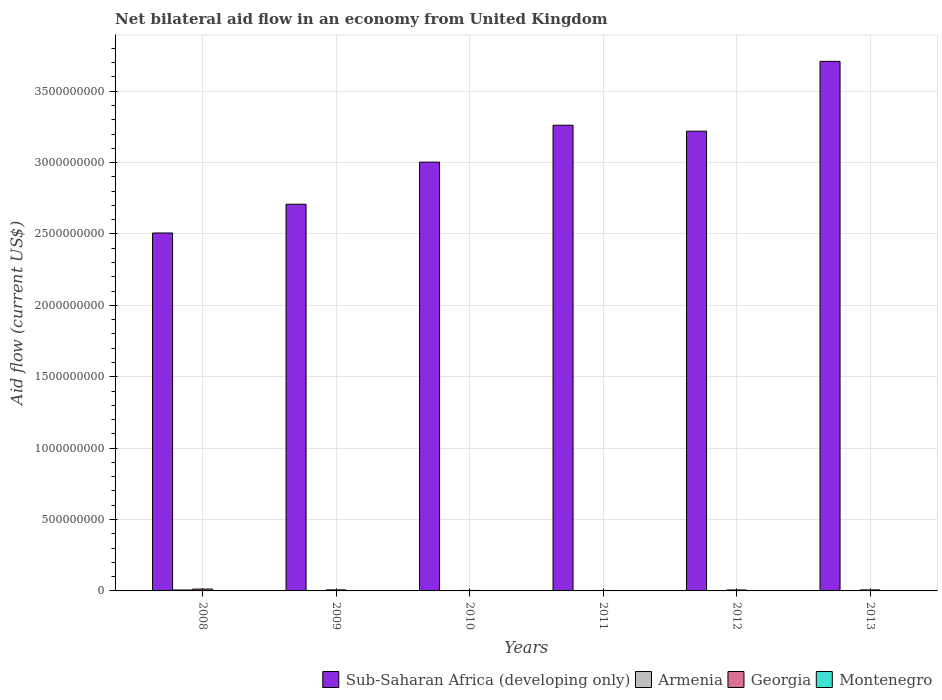Are the number of bars on each tick of the X-axis equal?
Offer a very short reply. Yes. How many bars are there on the 6th tick from the left?
Your answer should be compact. 4. How many bars are there on the 4th tick from the right?
Your answer should be very brief. 4. What is the net bilateral aid flow in Georgia in 2010?
Provide a succinct answer. 3.43e+06. Across all years, what is the maximum net bilateral aid flow in Montenegro?
Ensure brevity in your answer.  8.40e+05. Across all years, what is the minimum net bilateral aid flow in Armenia?
Keep it short and to the point. 3.60e+05. What is the total net bilateral aid flow in Sub-Saharan Africa (developing only) in the graph?
Provide a short and direct response. 1.84e+1. What is the difference between the net bilateral aid flow in Montenegro in 2008 and that in 2013?
Offer a terse response. -1.00e+05. What is the difference between the net bilateral aid flow in Georgia in 2012 and the net bilateral aid flow in Montenegro in 2013?
Your response must be concise. 5.93e+06. What is the average net bilateral aid flow in Armenia per year?
Offer a very short reply. 1.85e+06. In the year 2008, what is the difference between the net bilateral aid flow in Montenegro and net bilateral aid flow in Armenia?
Your answer should be very brief. -5.86e+06. What is the ratio of the net bilateral aid flow in Sub-Saharan Africa (developing only) in 2011 to that in 2012?
Give a very brief answer. 1.01. Is the difference between the net bilateral aid flow in Montenegro in 2011 and 2012 greater than the difference between the net bilateral aid flow in Armenia in 2011 and 2012?
Make the answer very short. Yes. What is the difference between the highest and the second highest net bilateral aid flow in Sub-Saharan Africa (developing only)?
Give a very brief answer. 4.47e+08. What is the difference between the highest and the lowest net bilateral aid flow in Sub-Saharan Africa (developing only)?
Give a very brief answer. 1.20e+09. In how many years, is the net bilateral aid flow in Sub-Saharan Africa (developing only) greater than the average net bilateral aid flow in Sub-Saharan Africa (developing only) taken over all years?
Make the answer very short. 3. Is the sum of the net bilateral aid flow in Armenia in 2009 and 2010 greater than the maximum net bilateral aid flow in Sub-Saharan Africa (developing only) across all years?
Ensure brevity in your answer.  No. What does the 1st bar from the left in 2010 represents?
Give a very brief answer. Sub-Saharan Africa (developing only). What does the 1st bar from the right in 2009 represents?
Keep it short and to the point. Montenegro. Is it the case that in every year, the sum of the net bilateral aid flow in Sub-Saharan Africa (developing only) and net bilateral aid flow in Armenia is greater than the net bilateral aid flow in Georgia?
Keep it short and to the point. Yes. Are all the bars in the graph horizontal?
Your answer should be compact. No. How many years are there in the graph?
Give a very brief answer. 6. Does the graph contain grids?
Offer a very short reply. Yes. Where does the legend appear in the graph?
Make the answer very short. Bottom right. How are the legend labels stacked?
Your response must be concise. Horizontal. What is the title of the graph?
Ensure brevity in your answer.  Net bilateral aid flow in an economy from United Kingdom. Does "High income" appear as one of the legend labels in the graph?
Offer a very short reply. No. What is the label or title of the X-axis?
Offer a very short reply. Years. What is the Aid flow (current US$) in Sub-Saharan Africa (developing only) in 2008?
Ensure brevity in your answer.  2.51e+09. What is the Aid flow (current US$) in Armenia in 2008?
Give a very brief answer. 6.60e+06. What is the Aid flow (current US$) in Georgia in 2008?
Ensure brevity in your answer.  1.28e+07. What is the Aid flow (current US$) of Montenegro in 2008?
Give a very brief answer. 7.40e+05. What is the Aid flow (current US$) in Sub-Saharan Africa (developing only) in 2009?
Offer a very short reply. 2.71e+09. What is the Aid flow (current US$) of Armenia in 2009?
Your response must be concise. 1.02e+06. What is the Aid flow (current US$) in Georgia in 2009?
Your answer should be compact. 7.25e+06. What is the Aid flow (current US$) of Montenegro in 2009?
Keep it short and to the point. 4.60e+05. What is the Aid flow (current US$) of Sub-Saharan Africa (developing only) in 2010?
Your response must be concise. 3.00e+09. What is the Aid flow (current US$) of Georgia in 2010?
Keep it short and to the point. 3.43e+06. What is the Aid flow (current US$) of Montenegro in 2010?
Your answer should be very brief. 2.10e+05. What is the Aid flow (current US$) in Sub-Saharan Africa (developing only) in 2011?
Your answer should be very brief. 3.26e+09. What is the Aid flow (current US$) of Armenia in 2011?
Keep it short and to the point. 3.60e+05. What is the Aid flow (current US$) of Georgia in 2011?
Offer a terse response. 3.19e+06. What is the Aid flow (current US$) in Sub-Saharan Africa (developing only) in 2012?
Your answer should be compact. 3.22e+09. What is the Aid flow (current US$) in Armenia in 2012?
Provide a short and direct response. 1.32e+06. What is the Aid flow (current US$) in Georgia in 2012?
Your answer should be compact. 6.77e+06. What is the Aid flow (current US$) of Montenegro in 2012?
Your answer should be compact. 7.70e+05. What is the Aid flow (current US$) in Sub-Saharan Africa (developing only) in 2013?
Provide a succinct answer. 3.71e+09. What is the Aid flow (current US$) in Armenia in 2013?
Your answer should be compact. 1.29e+06. What is the Aid flow (current US$) of Georgia in 2013?
Offer a very short reply. 7.04e+06. What is the Aid flow (current US$) of Montenegro in 2013?
Provide a short and direct response. 8.40e+05. Across all years, what is the maximum Aid flow (current US$) in Sub-Saharan Africa (developing only)?
Your answer should be compact. 3.71e+09. Across all years, what is the maximum Aid flow (current US$) in Armenia?
Your answer should be very brief. 6.60e+06. Across all years, what is the maximum Aid flow (current US$) in Georgia?
Your answer should be compact. 1.28e+07. Across all years, what is the maximum Aid flow (current US$) in Montenegro?
Make the answer very short. 8.40e+05. Across all years, what is the minimum Aid flow (current US$) of Sub-Saharan Africa (developing only)?
Ensure brevity in your answer.  2.51e+09. Across all years, what is the minimum Aid flow (current US$) in Armenia?
Make the answer very short. 3.60e+05. Across all years, what is the minimum Aid flow (current US$) of Georgia?
Provide a short and direct response. 3.19e+06. Across all years, what is the minimum Aid flow (current US$) of Montenegro?
Ensure brevity in your answer.  2.10e+05. What is the total Aid flow (current US$) of Sub-Saharan Africa (developing only) in the graph?
Offer a very short reply. 1.84e+1. What is the total Aid flow (current US$) in Armenia in the graph?
Your answer should be very brief. 1.11e+07. What is the total Aid flow (current US$) in Georgia in the graph?
Give a very brief answer. 4.05e+07. What is the total Aid flow (current US$) of Montenegro in the graph?
Provide a succinct answer. 3.35e+06. What is the difference between the Aid flow (current US$) of Sub-Saharan Africa (developing only) in 2008 and that in 2009?
Give a very brief answer. -2.01e+08. What is the difference between the Aid flow (current US$) in Armenia in 2008 and that in 2009?
Provide a short and direct response. 5.58e+06. What is the difference between the Aid flow (current US$) in Georgia in 2008 and that in 2009?
Provide a succinct answer. 5.58e+06. What is the difference between the Aid flow (current US$) in Sub-Saharan Africa (developing only) in 2008 and that in 2010?
Offer a terse response. -4.96e+08. What is the difference between the Aid flow (current US$) in Armenia in 2008 and that in 2010?
Provide a short and direct response. 6.11e+06. What is the difference between the Aid flow (current US$) of Georgia in 2008 and that in 2010?
Offer a terse response. 9.40e+06. What is the difference between the Aid flow (current US$) in Montenegro in 2008 and that in 2010?
Provide a short and direct response. 5.30e+05. What is the difference between the Aid flow (current US$) of Sub-Saharan Africa (developing only) in 2008 and that in 2011?
Provide a succinct answer. -7.55e+08. What is the difference between the Aid flow (current US$) of Armenia in 2008 and that in 2011?
Your answer should be compact. 6.24e+06. What is the difference between the Aid flow (current US$) in Georgia in 2008 and that in 2011?
Your answer should be very brief. 9.64e+06. What is the difference between the Aid flow (current US$) in Montenegro in 2008 and that in 2011?
Your answer should be compact. 4.10e+05. What is the difference between the Aid flow (current US$) of Sub-Saharan Africa (developing only) in 2008 and that in 2012?
Your answer should be compact. -7.13e+08. What is the difference between the Aid flow (current US$) of Armenia in 2008 and that in 2012?
Keep it short and to the point. 5.28e+06. What is the difference between the Aid flow (current US$) of Georgia in 2008 and that in 2012?
Keep it short and to the point. 6.06e+06. What is the difference between the Aid flow (current US$) in Sub-Saharan Africa (developing only) in 2008 and that in 2013?
Your answer should be very brief. -1.20e+09. What is the difference between the Aid flow (current US$) of Armenia in 2008 and that in 2013?
Give a very brief answer. 5.31e+06. What is the difference between the Aid flow (current US$) of Georgia in 2008 and that in 2013?
Your answer should be compact. 5.79e+06. What is the difference between the Aid flow (current US$) in Sub-Saharan Africa (developing only) in 2009 and that in 2010?
Your answer should be very brief. -2.95e+08. What is the difference between the Aid flow (current US$) in Armenia in 2009 and that in 2010?
Provide a succinct answer. 5.30e+05. What is the difference between the Aid flow (current US$) of Georgia in 2009 and that in 2010?
Ensure brevity in your answer.  3.82e+06. What is the difference between the Aid flow (current US$) in Montenegro in 2009 and that in 2010?
Your response must be concise. 2.50e+05. What is the difference between the Aid flow (current US$) in Sub-Saharan Africa (developing only) in 2009 and that in 2011?
Your answer should be very brief. -5.53e+08. What is the difference between the Aid flow (current US$) in Georgia in 2009 and that in 2011?
Make the answer very short. 4.06e+06. What is the difference between the Aid flow (current US$) in Montenegro in 2009 and that in 2011?
Offer a very short reply. 1.30e+05. What is the difference between the Aid flow (current US$) of Sub-Saharan Africa (developing only) in 2009 and that in 2012?
Ensure brevity in your answer.  -5.12e+08. What is the difference between the Aid flow (current US$) in Armenia in 2009 and that in 2012?
Your answer should be very brief. -3.00e+05. What is the difference between the Aid flow (current US$) in Georgia in 2009 and that in 2012?
Offer a very short reply. 4.80e+05. What is the difference between the Aid flow (current US$) of Montenegro in 2009 and that in 2012?
Give a very brief answer. -3.10e+05. What is the difference between the Aid flow (current US$) of Sub-Saharan Africa (developing only) in 2009 and that in 2013?
Your answer should be very brief. -1.00e+09. What is the difference between the Aid flow (current US$) in Georgia in 2009 and that in 2013?
Your answer should be very brief. 2.10e+05. What is the difference between the Aid flow (current US$) in Montenegro in 2009 and that in 2013?
Your answer should be very brief. -3.80e+05. What is the difference between the Aid flow (current US$) in Sub-Saharan Africa (developing only) in 2010 and that in 2011?
Offer a terse response. -2.59e+08. What is the difference between the Aid flow (current US$) of Armenia in 2010 and that in 2011?
Give a very brief answer. 1.30e+05. What is the difference between the Aid flow (current US$) of Georgia in 2010 and that in 2011?
Provide a short and direct response. 2.40e+05. What is the difference between the Aid flow (current US$) in Sub-Saharan Africa (developing only) in 2010 and that in 2012?
Keep it short and to the point. -2.17e+08. What is the difference between the Aid flow (current US$) in Armenia in 2010 and that in 2012?
Your response must be concise. -8.30e+05. What is the difference between the Aid flow (current US$) of Georgia in 2010 and that in 2012?
Your response must be concise. -3.34e+06. What is the difference between the Aid flow (current US$) in Montenegro in 2010 and that in 2012?
Make the answer very short. -5.60e+05. What is the difference between the Aid flow (current US$) in Sub-Saharan Africa (developing only) in 2010 and that in 2013?
Offer a very short reply. -7.06e+08. What is the difference between the Aid flow (current US$) of Armenia in 2010 and that in 2013?
Ensure brevity in your answer.  -8.00e+05. What is the difference between the Aid flow (current US$) of Georgia in 2010 and that in 2013?
Offer a terse response. -3.61e+06. What is the difference between the Aid flow (current US$) of Montenegro in 2010 and that in 2013?
Provide a short and direct response. -6.30e+05. What is the difference between the Aid flow (current US$) in Sub-Saharan Africa (developing only) in 2011 and that in 2012?
Your response must be concise. 4.16e+07. What is the difference between the Aid flow (current US$) in Armenia in 2011 and that in 2012?
Give a very brief answer. -9.60e+05. What is the difference between the Aid flow (current US$) in Georgia in 2011 and that in 2012?
Your response must be concise. -3.58e+06. What is the difference between the Aid flow (current US$) of Montenegro in 2011 and that in 2012?
Keep it short and to the point. -4.40e+05. What is the difference between the Aid flow (current US$) of Sub-Saharan Africa (developing only) in 2011 and that in 2013?
Your response must be concise. -4.47e+08. What is the difference between the Aid flow (current US$) in Armenia in 2011 and that in 2013?
Offer a terse response. -9.30e+05. What is the difference between the Aid flow (current US$) of Georgia in 2011 and that in 2013?
Keep it short and to the point. -3.85e+06. What is the difference between the Aid flow (current US$) of Montenegro in 2011 and that in 2013?
Your response must be concise. -5.10e+05. What is the difference between the Aid flow (current US$) of Sub-Saharan Africa (developing only) in 2012 and that in 2013?
Your answer should be compact. -4.89e+08. What is the difference between the Aid flow (current US$) of Montenegro in 2012 and that in 2013?
Your answer should be compact. -7.00e+04. What is the difference between the Aid flow (current US$) in Sub-Saharan Africa (developing only) in 2008 and the Aid flow (current US$) in Armenia in 2009?
Give a very brief answer. 2.51e+09. What is the difference between the Aid flow (current US$) in Sub-Saharan Africa (developing only) in 2008 and the Aid flow (current US$) in Georgia in 2009?
Offer a terse response. 2.50e+09. What is the difference between the Aid flow (current US$) in Sub-Saharan Africa (developing only) in 2008 and the Aid flow (current US$) in Montenegro in 2009?
Your answer should be compact. 2.51e+09. What is the difference between the Aid flow (current US$) in Armenia in 2008 and the Aid flow (current US$) in Georgia in 2009?
Ensure brevity in your answer.  -6.50e+05. What is the difference between the Aid flow (current US$) in Armenia in 2008 and the Aid flow (current US$) in Montenegro in 2009?
Offer a terse response. 6.14e+06. What is the difference between the Aid flow (current US$) of Georgia in 2008 and the Aid flow (current US$) of Montenegro in 2009?
Make the answer very short. 1.24e+07. What is the difference between the Aid flow (current US$) in Sub-Saharan Africa (developing only) in 2008 and the Aid flow (current US$) in Armenia in 2010?
Provide a succinct answer. 2.51e+09. What is the difference between the Aid flow (current US$) in Sub-Saharan Africa (developing only) in 2008 and the Aid flow (current US$) in Georgia in 2010?
Your answer should be compact. 2.50e+09. What is the difference between the Aid flow (current US$) of Sub-Saharan Africa (developing only) in 2008 and the Aid flow (current US$) of Montenegro in 2010?
Give a very brief answer. 2.51e+09. What is the difference between the Aid flow (current US$) in Armenia in 2008 and the Aid flow (current US$) in Georgia in 2010?
Ensure brevity in your answer.  3.17e+06. What is the difference between the Aid flow (current US$) of Armenia in 2008 and the Aid flow (current US$) of Montenegro in 2010?
Keep it short and to the point. 6.39e+06. What is the difference between the Aid flow (current US$) of Georgia in 2008 and the Aid flow (current US$) of Montenegro in 2010?
Offer a terse response. 1.26e+07. What is the difference between the Aid flow (current US$) of Sub-Saharan Africa (developing only) in 2008 and the Aid flow (current US$) of Armenia in 2011?
Your response must be concise. 2.51e+09. What is the difference between the Aid flow (current US$) in Sub-Saharan Africa (developing only) in 2008 and the Aid flow (current US$) in Georgia in 2011?
Give a very brief answer. 2.50e+09. What is the difference between the Aid flow (current US$) of Sub-Saharan Africa (developing only) in 2008 and the Aid flow (current US$) of Montenegro in 2011?
Ensure brevity in your answer.  2.51e+09. What is the difference between the Aid flow (current US$) in Armenia in 2008 and the Aid flow (current US$) in Georgia in 2011?
Give a very brief answer. 3.41e+06. What is the difference between the Aid flow (current US$) in Armenia in 2008 and the Aid flow (current US$) in Montenegro in 2011?
Provide a short and direct response. 6.27e+06. What is the difference between the Aid flow (current US$) in Georgia in 2008 and the Aid flow (current US$) in Montenegro in 2011?
Provide a short and direct response. 1.25e+07. What is the difference between the Aid flow (current US$) of Sub-Saharan Africa (developing only) in 2008 and the Aid flow (current US$) of Armenia in 2012?
Your response must be concise. 2.51e+09. What is the difference between the Aid flow (current US$) in Sub-Saharan Africa (developing only) in 2008 and the Aid flow (current US$) in Georgia in 2012?
Provide a succinct answer. 2.50e+09. What is the difference between the Aid flow (current US$) in Sub-Saharan Africa (developing only) in 2008 and the Aid flow (current US$) in Montenegro in 2012?
Provide a short and direct response. 2.51e+09. What is the difference between the Aid flow (current US$) of Armenia in 2008 and the Aid flow (current US$) of Montenegro in 2012?
Offer a very short reply. 5.83e+06. What is the difference between the Aid flow (current US$) in Georgia in 2008 and the Aid flow (current US$) in Montenegro in 2012?
Provide a short and direct response. 1.21e+07. What is the difference between the Aid flow (current US$) of Sub-Saharan Africa (developing only) in 2008 and the Aid flow (current US$) of Armenia in 2013?
Give a very brief answer. 2.51e+09. What is the difference between the Aid flow (current US$) in Sub-Saharan Africa (developing only) in 2008 and the Aid flow (current US$) in Georgia in 2013?
Make the answer very short. 2.50e+09. What is the difference between the Aid flow (current US$) in Sub-Saharan Africa (developing only) in 2008 and the Aid flow (current US$) in Montenegro in 2013?
Your response must be concise. 2.51e+09. What is the difference between the Aid flow (current US$) of Armenia in 2008 and the Aid flow (current US$) of Georgia in 2013?
Your response must be concise. -4.40e+05. What is the difference between the Aid flow (current US$) in Armenia in 2008 and the Aid flow (current US$) in Montenegro in 2013?
Make the answer very short. 5.76e+06. What is the difference between the Aid flow (current US$) in Georgia in 2008 and the Aid flow (current US$) in Montenegro in 2013?
Keep it short and to the point. 1.20e+07. What is the difference between the Aid flow (current US$) of Sub-Saharan Africa (developing only) in 2009 and the Aid flow (current US$) of Armenia in 2010?
Offer a terse response. 2.71e+09. What is the difference between the Aid flow (current US$) in Sub-Saharan Africa (developing only) in 2009 and the Aid flow (current US$) in Georgia in 2010?
Give a very brief answer. 2.70e+09. What is the difference between the Aid flow (current US$) in Sub-Saharan Africa (developing only) in 2009 and the Aid flow (current US$) in Montenegro in 2010?
Provide a succinct answer. 2.71e+09. What is the difference between the Aid flow (current US$) of Armenia in 2009 and the Aid flow (current US$) of Georgia in 2010?
Make the answer very short. -2.41e+06. What is the difference between the Aid flow (current US$) in Armenia in 2009 and the Aid flow (current US$) in Montenegro in 2010?
Ensure brevity in your answer.  8.10e+05. What is the difference between the Aid flow (current US$) of Georgia in 2009 and the Aid flow (current US$) of Montenegro in 2010?
Your answer should be very brief. 7.04e+06. What is the difference between the Aid flow (current US$) in Sub-Saharan Africa (developing only) in 2009 and the Aid flow (current US$) in Armenia in 2011?
Your response must be concise. 2.71e+09. What is the difference between the Aid flow (current US$) in Sub-Saharan Africa (developing only) in 2009 and the Aid flow (current US$) in Georgia in 2011?
Offer a terse response. 2.71e+09. What is the difference between the Aid flow (current US$) of Sub-Saharan Africa (developing only) in 2009 and the Aid flow (current US$) of Montenegro in 2011?
Provide a succinct answer. 2.71e+09. What is the difference between the Aid flow (current US$) of Armenia in 2009 and the Aid flow (current US$) of Georgia in 2011?
Give a very brief answer. -2.17e+06. What is the difference between the Aid flow (current US$) of Armenia in 2009 and the Aid flow (current US$) of Montenegro in 2011?
Your answer should be very brief. 6.90e+05. What is the difference between the Aid flow (current US$) of Georgia in 2009 and the Aid flow (current US$) of Montenegro in 2011?
Keep it short and to the point. 6.92e+06. What is the difference between the Aid flow (current US$) in Sub-Saharan Africa (developing only) in 2009 and the Aid flow (current US$) in Armenia in 2012?
Offer a terse response. 2.71e+09. What is the difference between the Aid flow (current US$) in Sub-Saharan Africa (developing only) in 2009 and the Aid flow (current US$) in Georgia in 2012?
Give a very brief answer. 2.70e+09. What is the difference between the Aid flow (current US$) in Sub-Saharan Africa (developing only) in 2009 and the Aid flow (current US$) in Montenegro in 2012?
Your answer should be very brief. 2.71e+09. What is the difference between the Aid flow (current US$) of Armenia in 2009 and the Aid flow (current US$) of Georgia in 2012?
Provide a succinct answer. -5.75e+06. What is the difference between the Aid flow (current US$) of Georgia in 2009 and the Aid flow (current US$) of Montenegro in 2012?
Give a very brief answer. 6.48e+06. What is the difference between the Aid flow (current US$) of Sub-Saharan Africa (developing only) in 2009 and the Aid flow (current US$) of Armenia in 2013?
Provide a short and direct response. 2.71e+09. What is the difference between the Aid flow (current US$) in Sub-Saharan Africa (developing only) in 2009 and the Aid flow (current US$) in Georgia in 2013?
Offer a very short reply. 2.70e+09. What is the difference between the Aid flow (current US$) in Sub-Saharan Africa (developing only) in 2009 and the Aid flow (current US$) in Montenegro in 2013?
Give a very brief answer. 2.71e+09. What is the difference between the Aid flow (current US$) of Armenia in 2009 and the Aid flow (current US$) of Georgia in 2013?
Provide a short and direct response. -6.02e+06. What is the difference between the Aid flow (current US$) in Armenia in 2009 and the Aid flow (current US$) in Montenegro in 2013?
Give a very brief answer. 1.80e+05. What is the difference between the Aid flow (current US$) of Georgia in 2009 and the Aid flow (current US$) of Montenegro in 2013?
Keep it short and to the point. 6.41e+06. What is the difference between the Aid flow (current US$) in Sub-Saharan Africa (developing only) in 2010 and the Aid flow (current US$) in Armenia in 2011?
Offer a very short reply. 3.00e+09. What is the difference between the Aid flow (current US$) in Sub-Saharan Africa (developing only) in 2010 and the Aid flow (current US$) in Georgia in 2011?
Your response must be concise. 3.00e+09. What is the difference between the Aid flow (current US$) in Sub-Saharan Africa (developing only) in 2010 and the Aid flow (current US$) in Montenegro in 2011?
Make the answer very short. 3.00e+09. What is the difference between the Aid flow (current US$) of Armenia in 2010 and the Aid flow (current US$) of Georgia in 2011?
Provide a succinct answer. -2.70e+06. What is the difference between the Aid flow (current US$) in Armenia in 2010 and the Aid flow (current US$) in Montenegro in 2011?
Ensure brevity in your answer.  1.60e+05. What is the difference between the Aid flow (current US$) in Georgia in 2010 and the Aid flow (current US$) in Montenegro in 2011?
Provide a short and direct response. 3.10e+06. What is the difference between the Aid flow (current US$) of Sub-Saharan Africa (developing only) in 2010 and the Aid flow (current US$) of Armenia in 2012?
Give a very brief answer. 3.00e+09. What is the difference between the Aid flow (current US$) of Sub-Saharan Africa (developing only) in 2010 and the Aid flow (current US$) of Georgia in 2012?
Your answer should be very brief. 3.00e+09. What is the difference between the Aid flow (current US$) in Sub-Saharan Africa (developing only) in 2010 and the Aid flow (current US$) in Montenegro in 2012?
Your answer should be compact. 3.00e+09. What is the difference between the Aid flow (current US$) of Armenia in 2010 and the Aid flow (current US$) of Georgia in 2012?
Give a very brief answer. -6.28e+06. What is the difference between the Aid flow (current US$) of Armenia in 2010 and the Aid flow (current US$) of Montenegro in 2012?
Make the answer very short. -2.80e+05. What is the difference between the Aid flow (current US$) in Georgia in 2010 and the Aid flow (current US$) in Montenegro in 2012?
Offer a terse response. 2.66e+06. What is the difference between the Aid flow (current US$) in Sub-Saharan Africa (developing only) in 2010 and the Aid flow (current US$) in Armenia in 2013?
Ensure brevity in your answer.  3.00e+09. What is the difference between the Aid flow (current US$) of Sub-Saharan Africa (developing only) in 2010 and the Aid flow (current US$) of Georgia in 2013?
Provide a succinct answer. 3.00e+09. What is the difference between the Aid flow (current US$) of Sub-Saharan Africa (developing only) in 2010 and the Aid flow (current US$) of Montenegro in 2013?
Offer a terse response. 3.00e+09. What is the difference between the Aid flow (current US$) of Armenia in 2010 and the Aid flow (current US$) of Georgia in 2013?
Your answer should be compact. -6.55e+06. What is the difference between the Aid flow (current US$) in Armenia in 2010 and the Aid flow (current US$) in Montenegro in 2013?
Your answer should be very brief. -3.50e+05. What is the difference between the Aid flow (current US$) of Georgia in 2010 and the Aid flow (current US$) of Montenegro in 2013?
Give a very brief answer. 2.59e+06. What is the difference between the Aid flow (current US$) of Sub-Saharan Africa (developing only) in 2011 and the Aid flow (current US$) of Armenia in 2012?
Give a very brief answer. 3.26e+09. What is the difference between the Aid flow (current US$) of Sub-Saharan Africa (developing only) in 2011 and the Aid flow (current US$) of Georgia in 2012?
Offer a terse response. 3.26e+09. What is the difference between the Aid flow (current US$) of Sub-Saharan Africa (developing only) in 2011 and the Aid flow (current US$) of Montenegro in 2012?
Your response must be concise. 3.26e+09. What is the difference between the Aid flow (current US$) of Armenia in 2011 and the Aid flow (current US$) of Georgia in 2012?
Make the answer very short. -6.41e+06. What is the difference between the Aid flow (current US$) in Armenia in 2011 and the Aid flow (current US$) in Montenegro in 2012?
Offer a very short reply. -4.10e+05. What is the difference between the Aid flow (current US$) in Georgia in 2011 and the Aid flow (current US$) in Montenegro in 2012?
Keep it short and to the point. 2.42e+06. What is the difference between the Aid flow (current US$) in Sub-Saharan Africa (developing only) in 2011 and the Aid flow (current US$) in Armenia in 2013?
Your answer should be very brief. 3.26e+09. What is the difference between the Aid flow (current US$) of Sub-Saharan Africa (developing only) in 2011 and the Aid flow (current US$) of Georgia in 2013?
Your answer should be very brief. 3.25e+09. What is the difference between the Aid flow (current US$) in Sub-Saharan Africa (developing only) in 2011 and the Aid flow (current US$) in Montenegro in 2013?
Your answer should be very brief. 3.26e+09. What is the difference between the Aid flow (current US$) in Armenia in 2011 and the Aid flow (current US$) in Georgia in 2013?
Keep it short and to the point. -6.68e+06. What is the difference between the Aid flow (current US$) of Armenia in 2011 and the Aid flow (current US$) of Montenegro in 2013?
Provide a short and direct response. -4.80e+05. What is the difference between the Aid flow (current US$) of Georgia in 2011 and the Aid flow (current US$) of Montenegro in 2013?
Make the answer very short. 2.35e+06. What is the difference between the Aid flow (current US$) of Sub-Saharan Africa (developing only) in 2012 and the Aid flow (current US$) of Armenia in 2013?
Provide a short and direct response. 3.22e+09. What is the difference between the Aid flow (current US$) of Sub-Saharan Africa (developing only) in 2012 and the Aid flow (current US$) of Georgia in 2013?
Give a very brief answer. 3.21e+09. What is the difference between the Aid flow (current US$) of Sub-Saharan Africa (developing only) in 2012 and the Aid flow (current US$) of Montenegro in 2013?
Keep it short and to the point. 3.22e+09. What is the difference between the Aid flow (current US$) of Armenia in 2012 and the Aid flow (current US$) of Georgia in 2013?
Keep it short and to the point. -5.72e+06. What is the difference between the Aid flow (current US$) of Georgia in 2012 and the Aid flow (current US$) of Montenegro in 2013?
Provide a short and direct response. 5.93e+06. What is the average Aid flow (current US$) in Sub-Saharan Africa (developing only) per year?
Give a very brief answer. 3.07e+09. What is the average Aid flow (current US$) of Armenia per year?
Ensure brevity in your answer.  1.85e+06. What is the average Aid flow (current US$) of Georgia per year?
Keep it short and to the point. 6.75e+06. What is the average Aid flow (current US$) of Montenegro per year?
Your answer should be very brief. 5.58e+05. In the year 2008, what is the difference between the Aid flow (current US$) of Sub-Saharan Africa (developing only) and Aid flow (current US$) of Armenia?
Offer a terse response. 2.50e+09. In the year 2008, what is the difference between the Aid flow (current US$) of Sub-Saharan Africa (developing only) and Aid flow (current US$) of Georgia?
Make the answer very short. 2.49e+09. In the year 2008, what is the difference between the Aid flow (current US$) in Sub-Saharan Africa (developing only) and Aid flow (current US$) in Montenegro?
Make the answer very short. 2.51e+09. In the year 2008, what is the difference between the Aid flow (current US$) in Armenia and Aid flow (current US$) in Georgia?
Provide a succinct answer. -6.23e+06. In the year 2008, what is the difference between the Aid flow (current US$) in Armenia and Aid flow (current US$) in Montenegro?
Provide a short and direct response. 5.86e+06. In the year 2008, what is the difference between the Aid flow (current US$) in Georgia and Aid flow (current US$) in Montenegro?
Provide a short and direct response. 1.21e+07. In the year 2009, what is the difference between the Aid flow (current US$) of Sub-Saharan Africa (developing only) and Aid flow (current US$) of Armenia?
Provide a succinct answer. 2.71e+09. In the year 2009, what is the difference between the Aid flow (current US$) in Sub-Saharan Africa (developing only) and Aid flow (current US$) in Georgia?
Make the answer very short. 2.70e+09. In the year 2009, what is the difference between the Aid flow (current US$) of Sub-Saharan Africa (developing only) and Aid flow (current US$) of Montenegro?
Offer a very short reply. 2.71e+09. In the year 2009, what is the difference between the Aid flow (current US$) in Armenia and Aid flow (current US$) in Georgia?
Keep it short and to the point. -6.23e+06. In the year 2009, what is the difference between the Aid flow (current US$) in Armenia and Aid flow (current US$) in Montenegro?
Ensure brevity in your answer.  5.60e+05. In the year 2009, what is the difference between the Aid flow (current US$) in Georgia and Aid flow (current US$) in Montenegro?
Provide a short and direct response. 6.79e+06. In the year 2010, what is the difference between the Aid flow (current US$) of Sub-Saharan Africa (developing only) and Aid flow (current US$) of Armenia?
Provide a short and direct response. 3.00e+09. In the year 2010, what is the difference between the Aid flow (current US$) of Sub-Saharan Africa (developing only) and Aid flow (current US$) of Georgia?
Ensure brevity in your answer.  3.00e+09. In the year 2010, what is the difference between the Aid flow (current US$) of Sub-Saharan Africa (developing only) and Aid flow (current US$) of Montenegro?
Provide a short and direct response. 3.00e+09. In the year 2010, what is the difference between the Aid flow (current US$) of Armenia and Aid flow (current US$) of Georgia?
Your answer should be compact. -2.94e+06. In the year 2010, what is the difference between the Aid flow (current US$) in Armenia and Aid flow (current US$) in Montenegro?
Your answer should be very brief. 2.80e+05. In the year 2010, what is the difference between the Aid flow (current US$) in Georgia and Aid flow (current US$) in Montenegro?
Your answer should be very brief. 3.22e+06. In the year 2011, what is the difference between the Aid flow (current US$) of Sub-Saharan Africa (developing only) and Aid flow (current US$) of Armenia?
Your answer should be compact. 3.26e+09. In the year 2011, what is the difference between the Aid flow (current US$) of Sub-Saharan Africa (developing only) and Aid flow (current US$) of Georgia?
Offer a very short reply. 3.26e+09. In the year 2011, what is the difference between the Aid flow (current US$) of Sub-Saharan Africa (developing only) and Aid flow (current US$) of Montenegro?
Keep it short and to the point. 3.26e+09. In the year 2011, what is the difference between the Aid flow (current US$) in Armenia and Aid flow (current US$) in Georgia?
Provide a short and direct response. -2.83e+06. In the year 2011, what is the difference between the Aid flow (current US$) in Armenia and Aid flow (current US$) in Montenegro?
Offer a very short reply. 3.00e+04. In the year 2011, what is the difference between the Aid flow (current US$) of Georgia and Aid flow (current US$) of Montenegro?
Provide a succinct answer. 2.86e+06. In the year 2012, what is the difference between the Aid flow (current US$) in Sub-Saharan Africa (developing only) and Aid flow (current US$) in Armenia?
Your answer should be very brief. 3.22e+09. In the year 2012, what is the difference between the Aid flow (current US$) of Sub-Saharan Africa (developing only) and Aid flow (current US$) of Georgia?
Your response must be concise. 3.21e+09. In the year 2012, what is the difference between the Aid flow (current US$) of Sub-Saharan Africa (developing only) and Aid flow (current US$) of Montenegro?
Offer a terse response. 3.22e+09. In the year 2012, what is the difference between the Aid flow (current US$) of Armenia and Aid flow (current US$) of Georgia?
Offer a terse response. -5.45e+06. In the year 2012, what is the difference between the Aid flow (current US$) of Armenia and Aid flow (current US$) of Montenegro?
Keep it short and to the point. 5.50e+05. In the year 2013, what is the difference between the Aid flow (current US$) in Sub-Saharan Africa (developing only) and Aid flow (current US$) in Armenia?
Ensure brevity in your answer.  3.71e+09. In the year 2013, what is the difference between the Aid flow (current US$) in Sub-Saharan Africa (developing only) and Aid flow (current US$) in Georgia?
Offer a terse response. 3.70e+09. In the year 2013, what is the difference between the Aid flow (current US$) in Sub-Saharan Africa (developing only) and Aid flow (current US$) in Montenegro?
Your response must be concise. 3.71e+09. In the year 2013, what is the difference between the Aid flow (current US$) in Armenia and Aid flow (current US$) in Georgia?
Make the answer very short. -5.75e+06. In the year 2013, what is the difference between the Aid flow (current US$) of Georgia and Aid flow (current US$) of Montenegro?
Your answer should be compact. 6.20e+06. What is the ratio of the Aid flow (current US$) in Sub-Saharan Africa (developing only) in 2008 to that in 2009?
Your answer should be compact. 0.93. What is the ratio of the Aid flow (current US$) of Armenia in 2008 to that in 2009?
Make the answer very short. 6.47. What is the ratio of the Aid flow (current US$) in Georgia in 2008 to that in 2009?
Your answer should be compact. 1.77. What is the ratio of the Aid flow (current US$) in Montenegro in 2008 to that in 2009?
Your answer should be very brief. 1.61. What is the ratio of the Aid flow (current US$) in Sub-Saharan Africa (developing only) in 2008 to that in 2010?
Offer a very short reply. 0.83. What is the ratio of the Aid flow (current US$) of Armenia in 2008 to that in 2010?
Your answer should be compact. 13.47. What is the ratio of the Aid flow (current US$) in Georgia in 2008 to that in 2010?
Provide a short and direct response. 3.74. What is the ratio of the Aid flow (current US$) in Montenegro in 2008 to that in 2010?
Keep it short and to the point. 3.52. What is the ratio of the Aid flow (current US$) of Sub-Saharan Africa (developing only) in 2008 to that in 2011?
Give a very brief answer. 0.77. What is the ratio of the Aid flow (current US$) of Armenia in 2008 to that in 2011?
Provide a short and direct response. 18.33. What is the ratio of the Aid flow (current US$) of Georgia in 2008 to that in 2011?
Ensure brevity in your answer.  4.02. What is the ratio of the Aid flow (current US$) of Montenegro in 2008 to that in 2011?
Offer a terse response. 2.24. What is the ratio of the Aid flow (current US$) of Sub-Saharan Africa (developing only) in 2008 to that in 2012?
Your answer should be compact. 0.78. What is the ratio of the Aid flow (current US$) in Georgia in 2008 to that in 2012?
Keep it short and to the point. 1.9. What is the ratio of the Aid flow (current US$) in Sub-Saharan Africa (developing only) in 2008 to that in 2013?
Provide a succinct answer. 0.68. What is the ratio of the Aid flow (current US$) in Armenia in 2008 to that in 2013?
Provide a short and direct response. 5.12. What is the ratio of the Aid flow (current US$) of Georgia in 2008 to that in 2013?
Your answer should be compact. 1.82. What is the ratio of the Aid flow (current US$) of Montenegro in 2008 to that in 2013?
Your response must be concise. 0.88. What is the ratio of the Aid flow (current US$) of Sub-Saharan Africa (developing only) in 2009 to that in 2010?
Ensure brevity in your answer.  0.9. What is the ratio of the Aid flow (current US$) in Armenia in 2009 to that in 2010?
Your response must be concise. 2.08. What is the ratio of the Aid flow (current US$) in Georgia in 2009 to that in 2010?
Your response must be concise. 2.11. What is the ratio of the Aid flow (current US$) in Montenegro in 2009 to that in 2010?
Your answer should be compact. 2.19. What is the ratio of the Aid flow (current US$) of Sub-Saharan Africa (developing only) in 2009 to that in 2011?
Keep it short and to the point. 0.83. What is the ratio of the Aid flow (current US$) in Armenia in 2009 to that in 2011?
Provide a succinct answer. 2.83. What is the ratio of the Aid flow (current US$) in Georgia in 2009 to that in 2011?
Your answer should be very brief. 2.27. What is the ratio of the Aid flow (current US$) of Montenegro in 2009 to that in 2011?
Make the answer very short. 1.39. What is the ratio of the Aid flow (current US$) of Sub-Saharan Africa (developing only) in 2009 to that in 2012?
Your answer should be compact. 0.84. What is the ratio of the Aid flow (current US$) of Armenia in 2009 to that in 2012?
Provide a succinct answer. 0.77. What is the ratio of the Aid flow (current US$) of Georgia in 2009 to that in 2012?
Give a very brief answer. 1.07. What is the ratio of the Aid flow (current US$) of Montenegro in 2009 to that in 2012?
Provide a short and direct response. 0.6. What is the ratio of the Aid flow (current US$) in Sub-Saharan Africa (developing only) in 2009 to that in 2013?
Make the answer very short. 0.73. What is the ratio of the Aid flow (current US$) of Armenia in 2009 to that in 2013?
Provide a succinct answer. 0.79. What is the ratio of the Aid flow (current US$) of Georgia in 2009 to that in 2013?
Provide a short and direct response. 1.03. What is the ratio of the Aid flow (current US$) in Montenegro in 2009 to that in 2013?
Give a very brief answer. 0.55. What is the ratio of the Aid flow (current US$) of Sub-Saharan Africa (developing only) in 2010 to that in 2011?
Provide a succinct answer. 0.92. What is the ratio of the Aid flow (current US$) in Armenia in 2010 to that in 2011?
Provide a succinct answer. 1.36. What is the ratio of the Aid flow (current US$) of Georgia in 2010 to that in 2011?
Offer a terse response. 1.08. What is the ratio of the Aid flow (current US$) of Montenegro in 2010 to that in 2011?
Make the answer very short. 0.64. What is the ratio of the Aid flow (current US$) in Sub-Saharan Africa (developing only) in 2010 to that in 2012?
Your answer should be compact. 0.93. What is the ratio of the Aid flow (current US$) in Armenia in 2010 to that in 2012?
Give a very brief answer. 0.37. What is the ratio of the Aid flow (current US$) in Georgia in 2010 to that in 2012?
Give a very brief answer. 0.51. What is the ratio of the Aid flow (current US$) of Montenegro in 2010 to that in 2012?
Your response must be concise. 0.27. What is the ratio of the Aid flow (current US$) of Sub-Saharan Africa (developing only) in 2010 to that in 2013?
Your answer should be very brief. 0.81. What is the ratio of the Aid flow (current US$) of Armenia in 2010 to that in 2013?
Make the answer very short. 0.38. What is the ratio of the Aid flow (current US$) in Georgia in 2010 to that in 2013?
Provide a succinct answer. 0.49. What is the ratio of the Aid flow (current US$) of Montenegro in 2010 to that in 2013?
Provide a short and direct response. 0.25. What is the ratio of the Aid flow (current US$) of Sub-Saharan Africa (developing only) in 2011 to that in 2012?
Provide a short and direct response. 1.01. What is the ratio of the Aid flow (current US$) of Armenia in 2011 to that in 2012?
Your answer should be compact. 0.27. What is the ratio of the Aid flow (current US$) of Georgia in 2011 to that in 2012?
Offer a terse response. 0.47. What is the ratio of the Aid flow (current US$) in Montenegro in 2011 to that in 2012?
Provide a succinct answer. 0.43. What is the ratio of the Aid flow (current US$) in Sub-Saharan Africa (developing only) in 2011 to that in 2013?
Give a very brief answer. 0.88. What is the ratio of the Aid flow (current US$) in Armenia in 2011 to that in 2013?
Provide a succinct answer. 0.28. What is the ratio of the Aid flow (current US$) of Georgia in 2011 to that in 2013?
Keep it short and to the point. 0.45. What is the ratio of the Aid flow (current US$) in Montenegro in 2011 to that in 2013?
Offer a very short reply. 0.39. What is the ratio of the Aid flow (current US$) in Sub-Saharan Africa (developing only) in 2012 to that in 2013?
Your response must be concise. 0.87. What is the ratio of the Aid flow (current US$) of Armenia in 2012 to that in 2013?
Ensure brevity in your answer.  1.02. What is the ratio of the Aid flow (current US$) of Georgia in 2012 to that in 2013?
Make the answer very short. 0.96. What is the difference between the highest and the second highest Aid flow (current US$) of Sub-Saharan Africa (developing only)?
Give a very brief answer. 4.47e+08. What is the difference between the highest and the second highest Aid flow (current US$) in Armenia?
Offer a very short reply. 5.28e+06. What is the difference between the highest and the second highest Aid flow (current US$) of Georgia?
Give a very brief answer. 5.58e+06. What is the difference between the highest and the second highest Aid flow (current US$) of Montenegro?
Provide a succinct answer. 7.00e+04. What is the difference between the highest and the lowest Aid flow (current US$) of Sub-Saharan Africa (developing only)?
Make the answer very short. 1.20e+09. What is the difference between the highest and the lowest Aid flow (current US$) of Armenia?
Your answer should be compact. 6.24e+06. What is the difference between the highest and the lowest Aid flow (current US$) in Georgia?
Offer a very short reply. 9.64e+06. What is the difference between the highest and the lowest Aid flow (current US$) of Montenegro?
Give a very brief answer. 6.30e+05. 